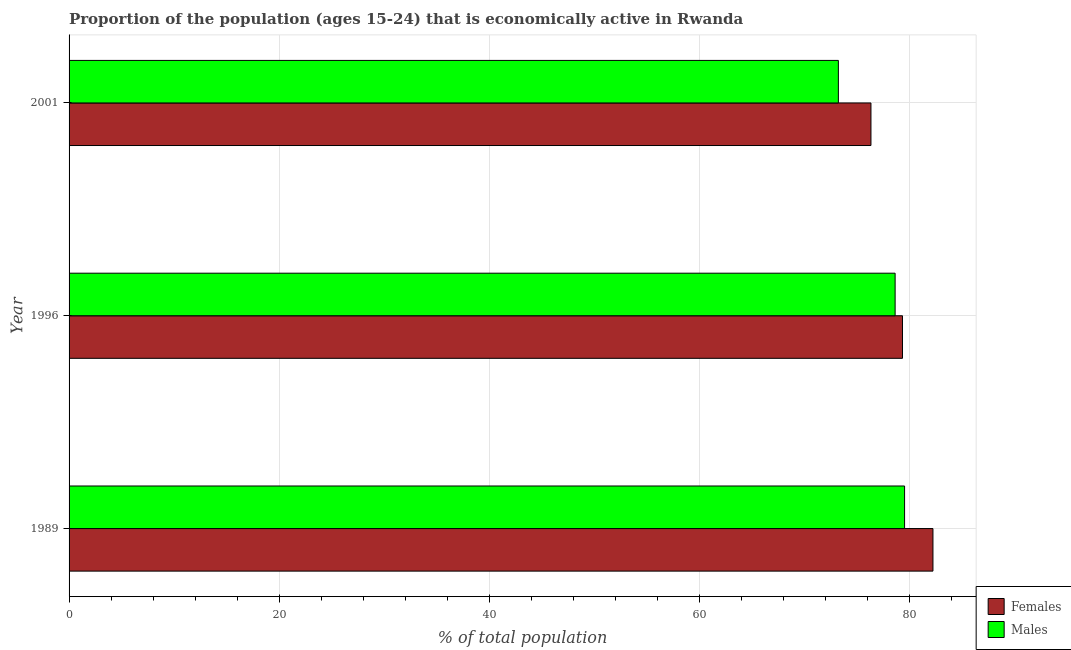How many different coloured bars are there?
Provide a succinct answer. 2. Are the number of bars on each tick of the Y-axis equal?
Provide a succinct answer. Yes. How many bars are there on the 2nd tick from the top?
Provide a succinct answer. 2. How many bars are there on the 3rd tick from the bottom?
Your answer should be compact. 2. What is the label of the 2nd group of bars from the top?
Make the answer very short. 1996. What is the percentage of economically active male population in 2001?
Ensure brevity in your answer.  73.2. Across all years, what is the maximum percentage of economically active male population?
Your response must be concise. 79.5. Across all years, what is the minimum percentage of economically active female population?
Offer a terse response. 76.3. In which year was the percentage of economically active male population maximum?
Provide a short and direct response. 1989. In which year was the percentage of economically active female population minimum?
Make the answer very short. 2001. What is the total percentage of economically active female population in the graph?
Make the answer very short. 237.8. What is the difference between the percentage of economically active female population in 1989 and that in 1996?
Give a very brief answer. 2.9. What is the average percentage of economically active male population per year?
Your answer should be very brief. 77.1. In the year 1996, what is the difference between the percentage of economically active male population and percentage of economically active female population?
Offer a very short reply. -0.7. Is the sum of the percentage of economically active male population in 1989 and 1996 greater than the maximum percentage of economically active female population across all years?
Make the answer very short. Yes. What does the 2nd bar from the top in 1989 represents?
Keep it short and to the point. Females. What does the 2nd bar from the bottom in 1989 represents?
Make the answer very short. Males. How many bars are there?
Offer a terse response. 6. How many years are there in the graph?
Your answer should be compact. 3. Are the values on the major ticks of X-axis written in scientific E-notation?
Ensure brevity in your answer.  No. Does the graph contain any zero values?
Keep it short and to the point. No. Where does the legend appear in the graph?
Make the answer very short. Bottom right. How are the legend labels stacked?
Make the answer very short. Vertical. What is the title of the graph?
Give a very brief answer. Proportion of the population (ages 15-24) that is economically active in Rwanda. What is the label or title of the X-axis?
Your answer should be very brief. % of total population. What is the % of total population of Females in 1989?
Your answer should be very brief. 82.2. What is the % of total population of Males in 1989?
Provide a short and direct response. 79.5. What is the % of total population in Females in 1996?
Keep it short and to the point. 79.3. What is the % of total population of Males in 1996?
Provide a succinct answer. 78.6. What is the % of total population in Females in 2001?
Your answer should be very brief. 76.3. What is the % of total population in Males in 2001?
Give a very brief answer. 73.2. Across all years, what is the maximum % of total population of Females?
Provide a succinct answer. 82.2. Across all years, what is the maximum % of total population in Males?
Give a very brief answer. 79.5. Across all years, what is the minimum % of total population of Females?
Ensure brevity in your answer.  76.3. Across all years, what is the minimum % of total population of Males?
Your answer should be very brief. 73.2. What is the total % of total population in Females in the graph?
Keep it short and to the point. 237.8. What is the total % of total population in Males in the graph?
Provide a succinct answer. 231.3. What is the difference between the % of total population of Females in 1989 and the % of total population of Males in 1996?
Provide a short and direct response. 3.6. What is the difference between the % of total population of Females in 1989 and the % of total population of Males in 2001?
Your answer should be compact. 9. What is the difference between the % of total population in Females in 1996 and the % of total population in Males in 2001?
Offer a terse response. 6.1. What is the average % of total population of Females per year?
Offer a very short reply. 79.27. What is the average % of total population in Males per year?
Offer a very short reply. 77.1. In the year 1989, what is the difference between the % of total population of Females and % of total population of Males?
Ensure brevity in your answer.  2.7. In the year 2001, what is the difference between the % of total population in Females and % of total population in Males?
Your answer should be compact. 3.1. What is the ratio of the % of total population of Females in 1989 to that in 1996?
Your response must be concise. 1.04. What is the ratio of the % of total population in Males in 1989 to that in 1996?
Your response must be concise. 1.01. What is the ratio of the % of total population in Females in 1989 to that in 2001?
Provide a succinct answer. 1.08. What is the ratio of the % of total population in Males in 1989 to that in 2001?
Make the answer very short. 1.09. What is the ratio of the % of total population of Females in 1996 to that in 2001?
Your response must be concise. 1.04. What is the ratio of the % of total population in Males in 1996 to that in 2001?
Offer a very short reply. 1.07. What is the difference between the highest and the second highest % of total population in Females?
Offer a terse response. 2.9. What is the difference between the highest and the lowest % of total population in Males?
Your answer should be very brief. 6.3. 